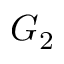<formula> <loc_0><loc_0><loc_500><loc_500>G _ { 2 }</formula> 